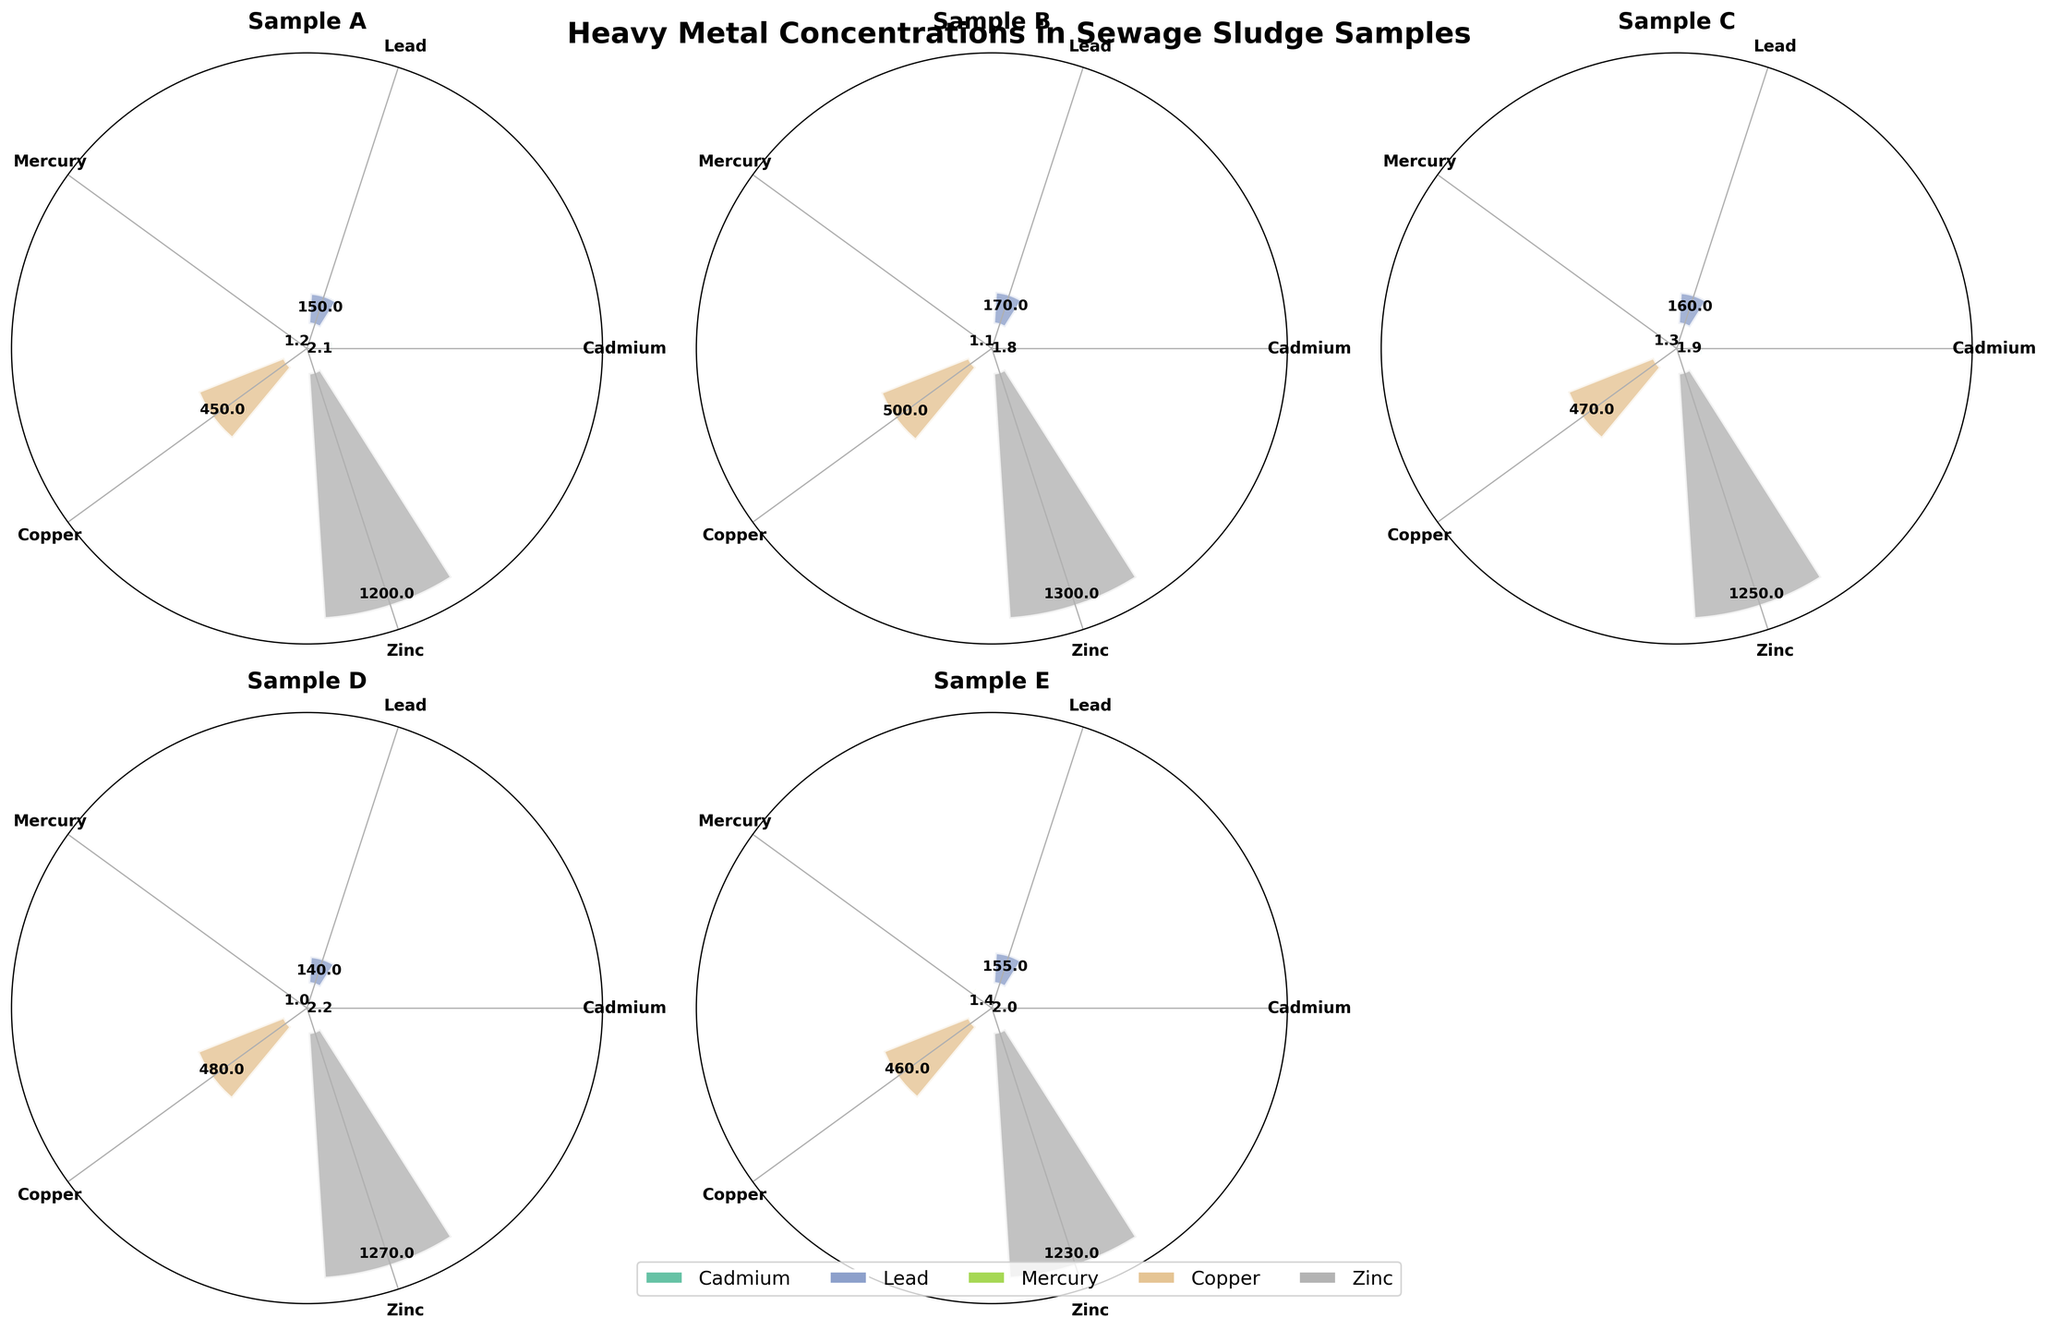What is the title of the figure? The title is written above the entire figure, usually in a bold and larger font size for emphasis.
Answer: Heavy Metal Concentrations in Sewage Sludge Samples How many heavy metals are displayed in the figure? The number of heavy metals can be counted by checking the unique labels in the charts.
Answer: 5 Which heavy metal has the highest concentration in Sample A? By looking at the bar heights in the subplot for Sample A, the tallest bar corresponds to the metal with the highest concentration.
Answer: Zinc What is the concentration of Cadmium in Sample B? In the subplot for Sample B, the numeric value next to the bar labeled Cadmium gives its concentration.
Answer: 1.8 mg/kg Compare the Mercury concentrations in Sample D and Sample E. Which sample has a higher concentration? By comparing the heights of the bars labeled Mercury in subplots D and E, the taller bar indicates the higher concentration.
Answer: Sample E How does the concentration of Lead in Sample C compare to that in Sample A? Compare the heights or the numeric values of the bars labeled Lead in subplots C and A.
Answer: Sample C has a lower concentration of Lead than Sample A What is the average concentration of Copper across all samples? Find the concentration values of Copper from each subplot and calculate their average: (450 + 500 + 470 + 480 + 460) / 5.
Answer: 472 mg/kg Which sample shows the lowest concentration of Mercury? Compare the Mercury bars in all subplots and identify the shortest one to find the lowest concentration.
Answer: Sample D Among all heavy metals, which one shows the most variation in concentration across all samples? By visually comparing the range of bar heights for each metal across all subplots, identify which metal has the widest variation.
Answer: Zinc Are there any metals for which the concentration is relatively stable across all samples? If so, which ones? Observe the consistency in bar heights for each metal across different subplots to determine stable concentrations.
Answer: Mercury and Cadmium 